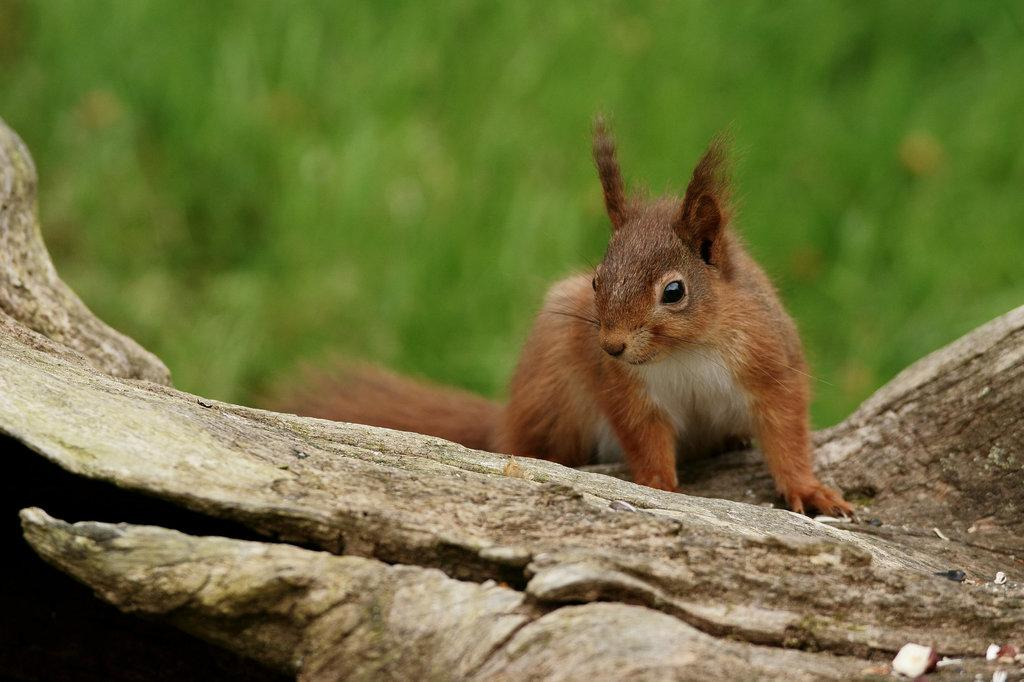What type of animal is in the image? There is a squirrel in the image. Can you describe the color of the squirrel? The squirrel has a brown and white color combination. What surface is the squirrel on? The squirrel is on a wooden surface. How would you describe the background of the image? The background of the image is blurred. Can you see any veins on the squirrel's tail in the image? There are no veins visible on the squirrel's tail in the image, as it is not a part of the squirrel's anatomy. 